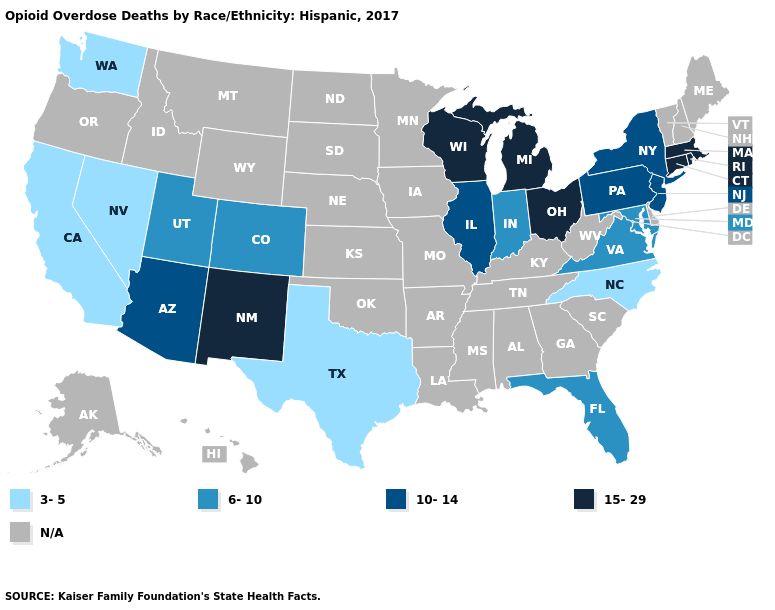Among the states that border Vermont , which have the lowest value?
Concise answer only. New York. Name the states that have a value in the range 3-5?
Keep it brief. California, Nevada, North Carolina, Texas, Washington. Does the first symbol in the legend represent the smallest category?
Be succinct. Yes. Does the first symbol in the legend represent the smallest category?
Give a very brief answer. Yes. What is the highest value in the West ?
Quick response, please. 15-29. Among the states that border Pennsylvania , does Maryland have the lowest value?
Answer briefly. Yes. Name the states that have a value in the range 10-14?
Write a very short answer. Arizona, Illinois, New Jersey, New York, Pennsylvania. What is the value of Arizona?
Answer briefly. 10-14. What is the lowest value in the West?
Quick response, please. 3-5. Name the states that have a value in the range 10-14?
Keep it brief. Arizona, Illinois, New Jersey, New York, Pennsylvania. What is the highest value in the Northeast ?
Write a very short answer. 15-29. What is the lowest value in states that border New Mexico?
Answer briefly. 3-5. What is the highest value in states that border Minnesota?
Be succinct. 15-29. 